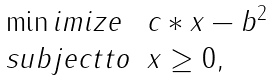<formula> <loc_0><loc_0><loc_500><loc_500>\begin{array} { l l } \min i m i z e & \| c * x - b \| ^ { 2 } \\ s u b j e c t t o & x \geq 0 , \end{array}</formula> 